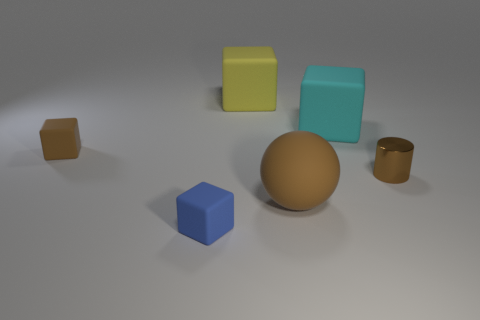Subtract all tiny brown matte blocks. How many blocks are left? 3 Subtract all cyan cubes. How many cubes are left? 3 Subtract 1 cubes. How many cubes are left? 3 Subtract all yellow blocks. Subtract all gray cylinders. How many blocks are left? 3 Add 3 tiny yellow matte cubes. How many objects exist? 9 Subtract 0 gray spheres. How many objects are left? 6 Subtract all cylinders. How many objects are left? 5 Subtract all red objects. Subtract all tiny objects. How many objects are left? 3 Add 4 brown rubber spheres. How many brown rubber spheres are left? 5 Add 5 big yellow matte cubes. How many big yellow matte cubes exist? 6 